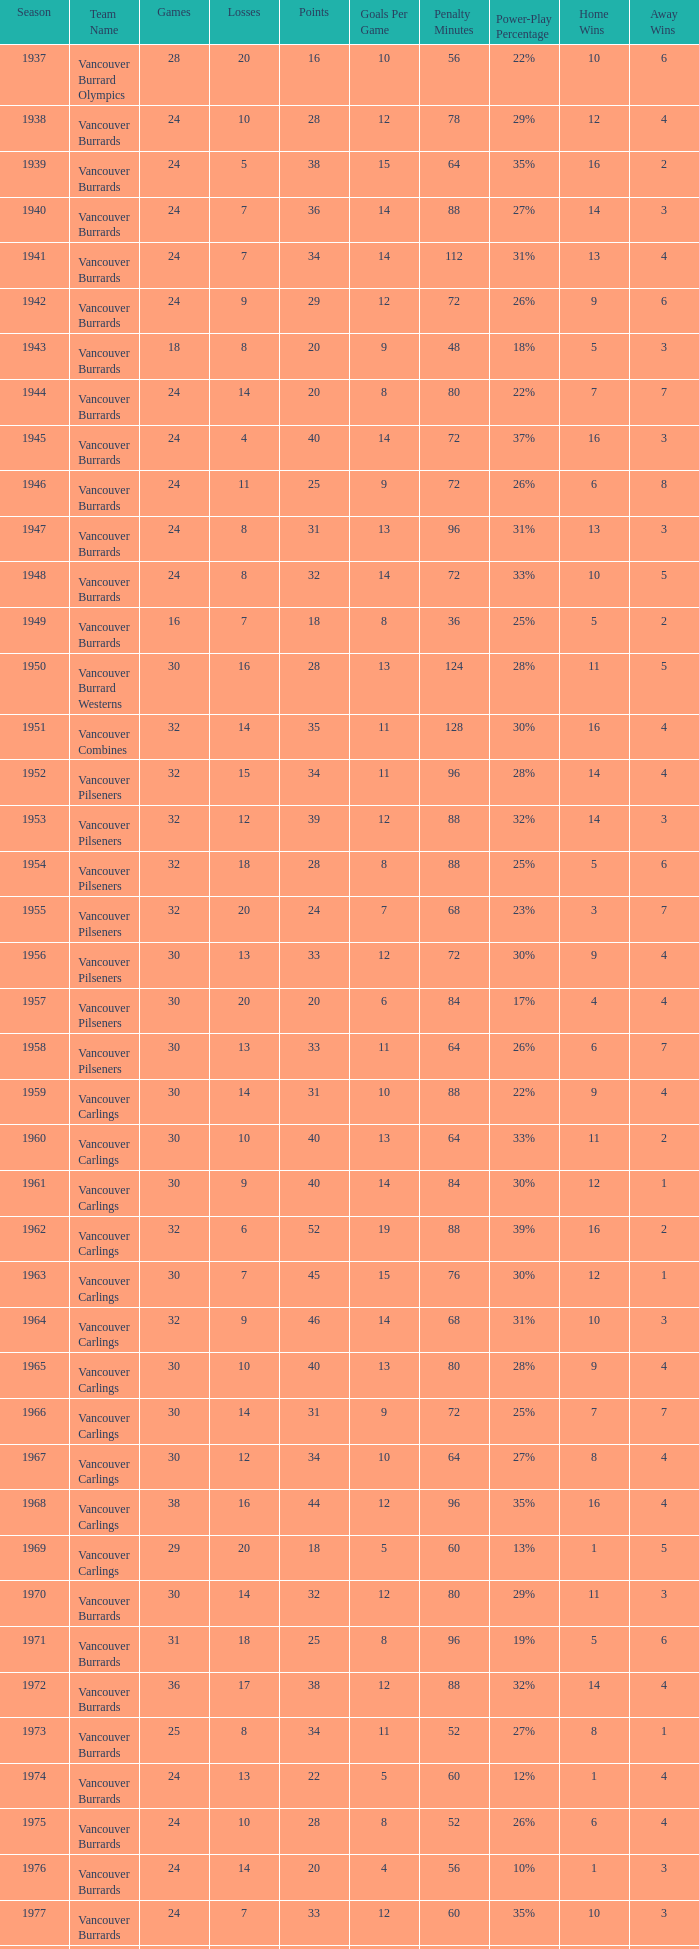What's the sum of points for the 1963 season when there are more than 30 games? None. 